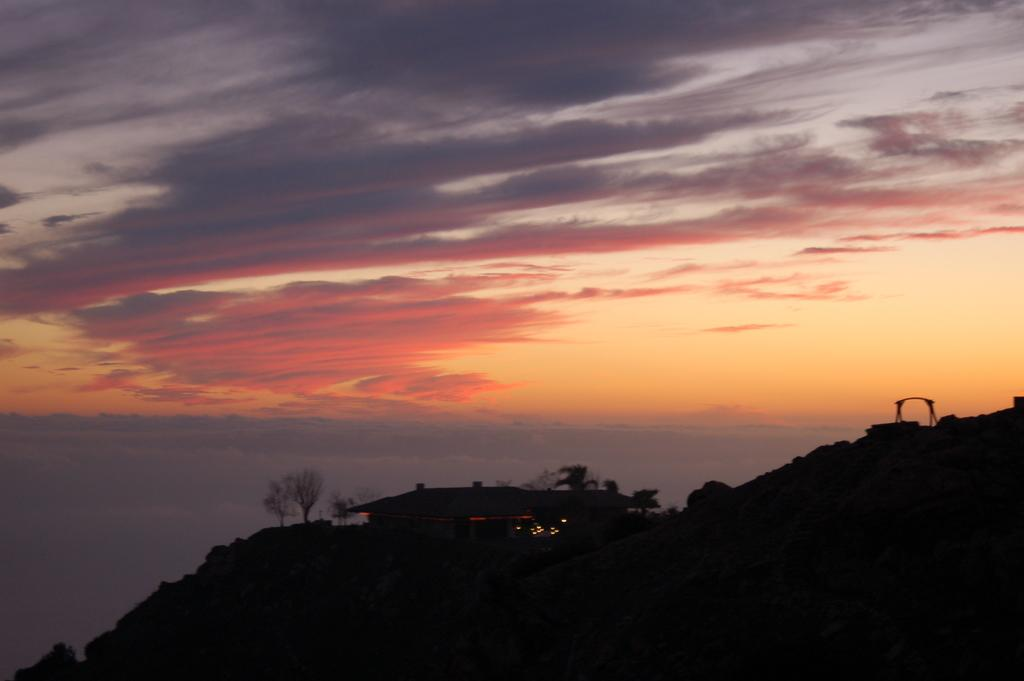What type of structure is visible in the image? There is a house in the image. What can be seen on the hill in the image? There are trees on a hill in the image. What is visible in the sky in the background of the image? There are clouds in the sky in the background of the image. How many eggs are on the plate in the image? There is no plate or eggs present in the image. What type of range is visible in the image? There is no range present in the image. 